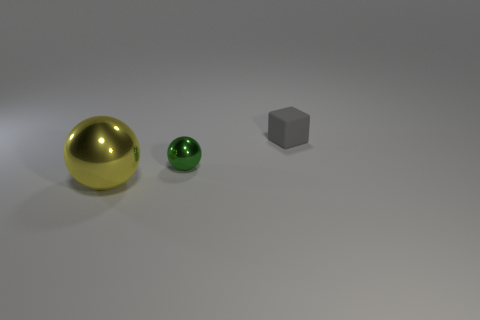Add 1 big yellow rubber cubes. How many objects exist? 4 Subtract all blocks. How many objects are left? 2 Add 1 large yellow spheres. How many large yellow spheres are left? 2 Add 1 small things. How many small things exist? 3 Subtract 1 gray blocks. How many objects are left? 2 Subtract all large blue cylinders. Subtract all metallic balls. How many objects are left? 1 